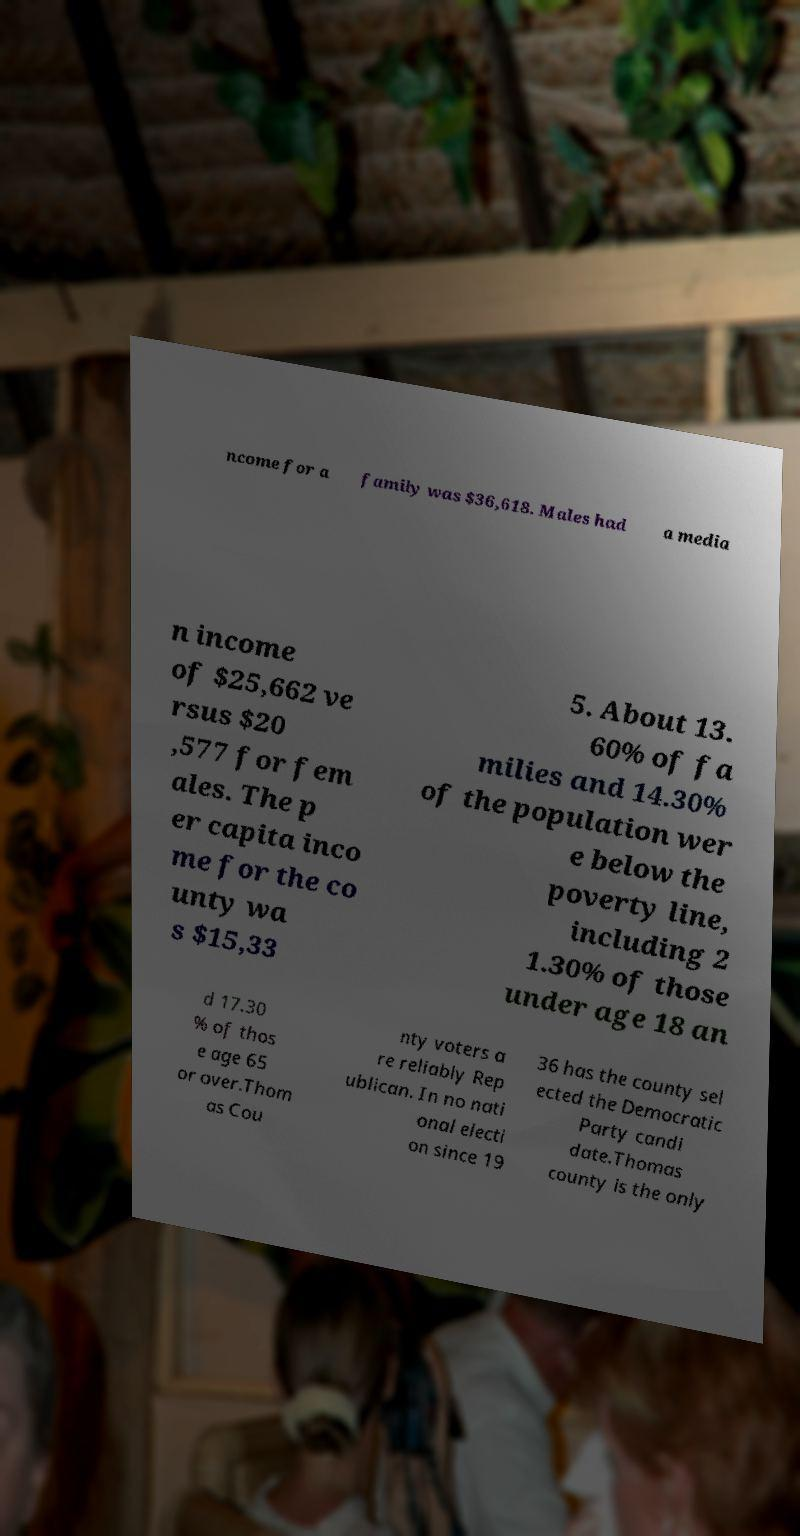Please identify and transcribe the text found in this image. ncome for a family was $36,618. Males had a media n income of $25,662 ve rsus $20 ,577 for fem ales. The p er capita inco me for the co unty wa s $15,33 5. About 13. 60% of fa milies and 14.30% of the population wer e below the poverty line, including 2 1.30% of those under age 18 an d 17.30 % of thos e age 65 or over.Thom as Cou nty voters a re reliably Rep ublican. In no nati onal electi on since 19 36 has the county sel ected the Democratic Party candi date.Thomas county is the only 